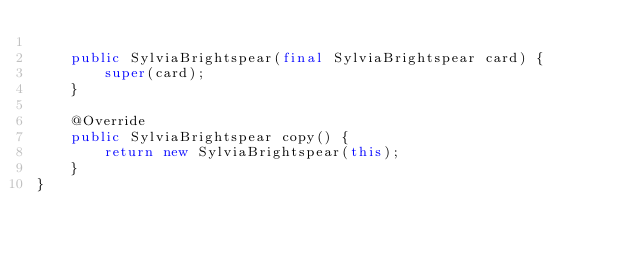<code> <loc_0><loc_0><loc_500><loc_500><_Java_>
    public SylviaBrightspear(final SylviaBrightspear card) {
        super(card);
    }

    @Override
    public SylviaBrightspear copy() {
        return new SylviaBrightspear(this);
    }
}
</code> 